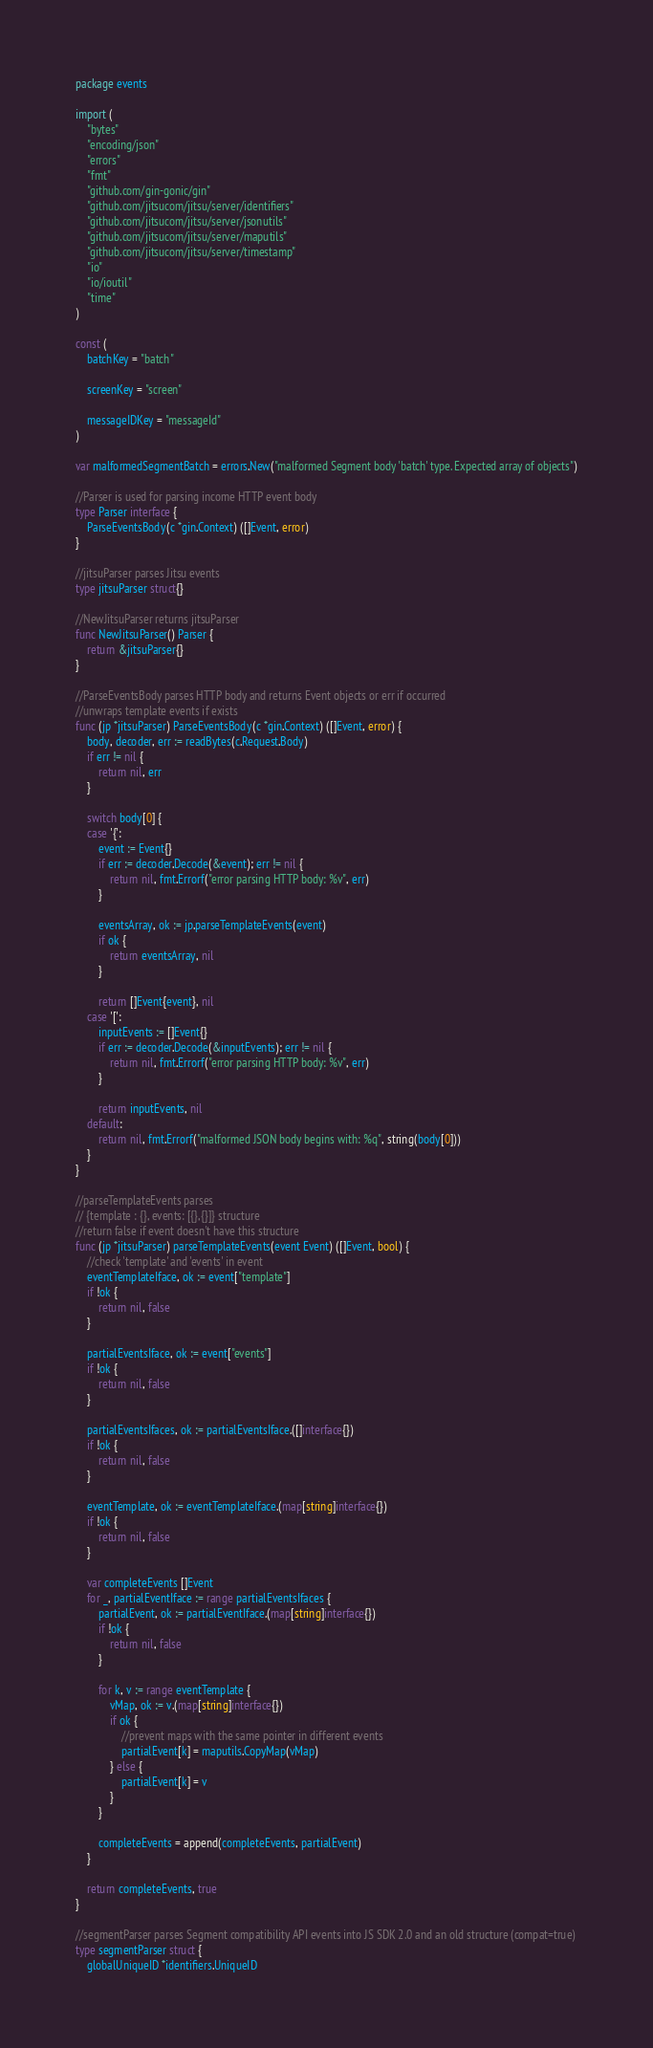<code> <loc_0><loc_0><loc_500><loc_500><_Go_>package events

import (
	"bytes"
	"encoding/json"
	"errors"
	"fmt"
	"github.com/gin-gonic/gin"
	"github.com/jitsucom/jitsu/server/identifiers"
	"github.com/jitsucom/jitsu/server/jsonutils"
	"github.com/jitsucom/jitsu/server/maputils"
	"github.com/jitsucom/jitsu/server/timestamp"
	"io"
	"io/ioutil"
	"time"
)

const (
	batchKey = "batch"

	screenKey = "screen"

	messageIDKey = "messageId"
)

var malformedSegmentBatch = errors.New("malformed Segment body 'batch' type. Expected array of objects")

//Parser is used for parsing income HTTP event body
type Parser interface {
	ParseEventsBody(c *gin.Context) ([]Event, error)
}

//jitsuParser parses Jitsu events
type jitsuParser struct{}

//NewJitsuParser returns jitsuParser
func NewJitsuParser() Parser {
	return &jitsuParser{}
}

//ParseEventsBody parses HTTP body and returns Event objects or err if occurred
//unwraps template events if exists
func (jp *jitsuParser) ParseEventsBody(c *gin.Context) ([]Event, error) {
	body, decoder, err := readBytes(c.Request.Body)
	if err != nil {
		return nil, err
	}

	switch body[0] {
	case '{':
		event := Event{}
		if err := decoder.Decode(&event); err != nil {
			return nil, fmt.Errorf("error parsing HTTP body: %v", err)
		}

		eventsArray, ok := jp.parseTemplateEvents(event)
		if ok {
			return eventsArray, nil
		}

		return []Event{event}, nil
	case '[':
		inputEvents := []Event{}
		if err := decoder.Decode(&inputEvents); err != nil {
			return nil, fmt.Errorf("error parsing HTTP body: %v", err)
		}

		return inputEvents, nil
	default:
		return nil, fmt.Errorf("malformed JSON body begins with: %q", string(body[0]))
	}
}

//parseTemplateEvents parses
// {template : {}, events: [{},{}]} structure
//return false if event doesn't have this structure
func (jp *jitsuParser) parseTemplateEvents(event Event) ([]Event, bool) {
	//check 'template' and 'events' in event
	eventTemplateIface, ok := event["template"]
	if !ok {
		return nil, false
	}

	partialEventsIface, ok := event["events"]
	if !ok {
		return nil, false
	}

	partialEventsIfaces, ok := partialEventsIface.([]interface{})
	if !ok {
		return nil, false
	}

	eventTemplate, ok := eventTemplateIface.(map[string]interface{})
	if !ok {
		return nil, false
	}

	var completeEvents []Event
	for _, partialEventIface := range partialEventsIfaces {
		partialEvent, ok := partialEventIface.(map[string]interface{})
		if !ok {
			return nil, false
		}

		for k, v := range eventTemplate {
			vMap, ok := v.(map[string]interface{})
			if ok {
				//prevent maps with the same pointer in different events
				partialEvent[k] = maputils.CopyMap(vMap)
			} else {
				partialEvent[k] = v
			}
		}

		completeEvents = append(completeEvents, partialEvent)
	}

	return completeEvents, true
}

//segmentParser parses Segment compatibility API events into JS SDK 2.0 and an old structure (compat=true)
type segmentParser struct {
	globalUniqueID *identifiers.UniqueID</code> 